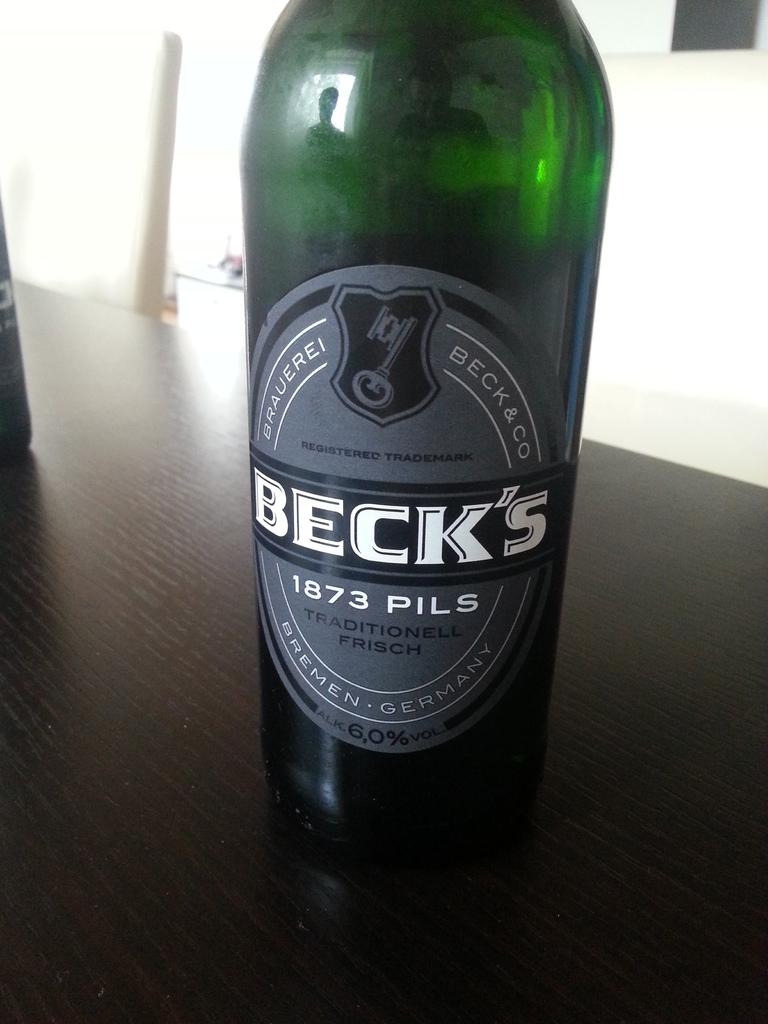<image>
Summarize the visual content of the image. A bottle of Beck's 1873 pilsner, brewed in Bremen, Germany. 